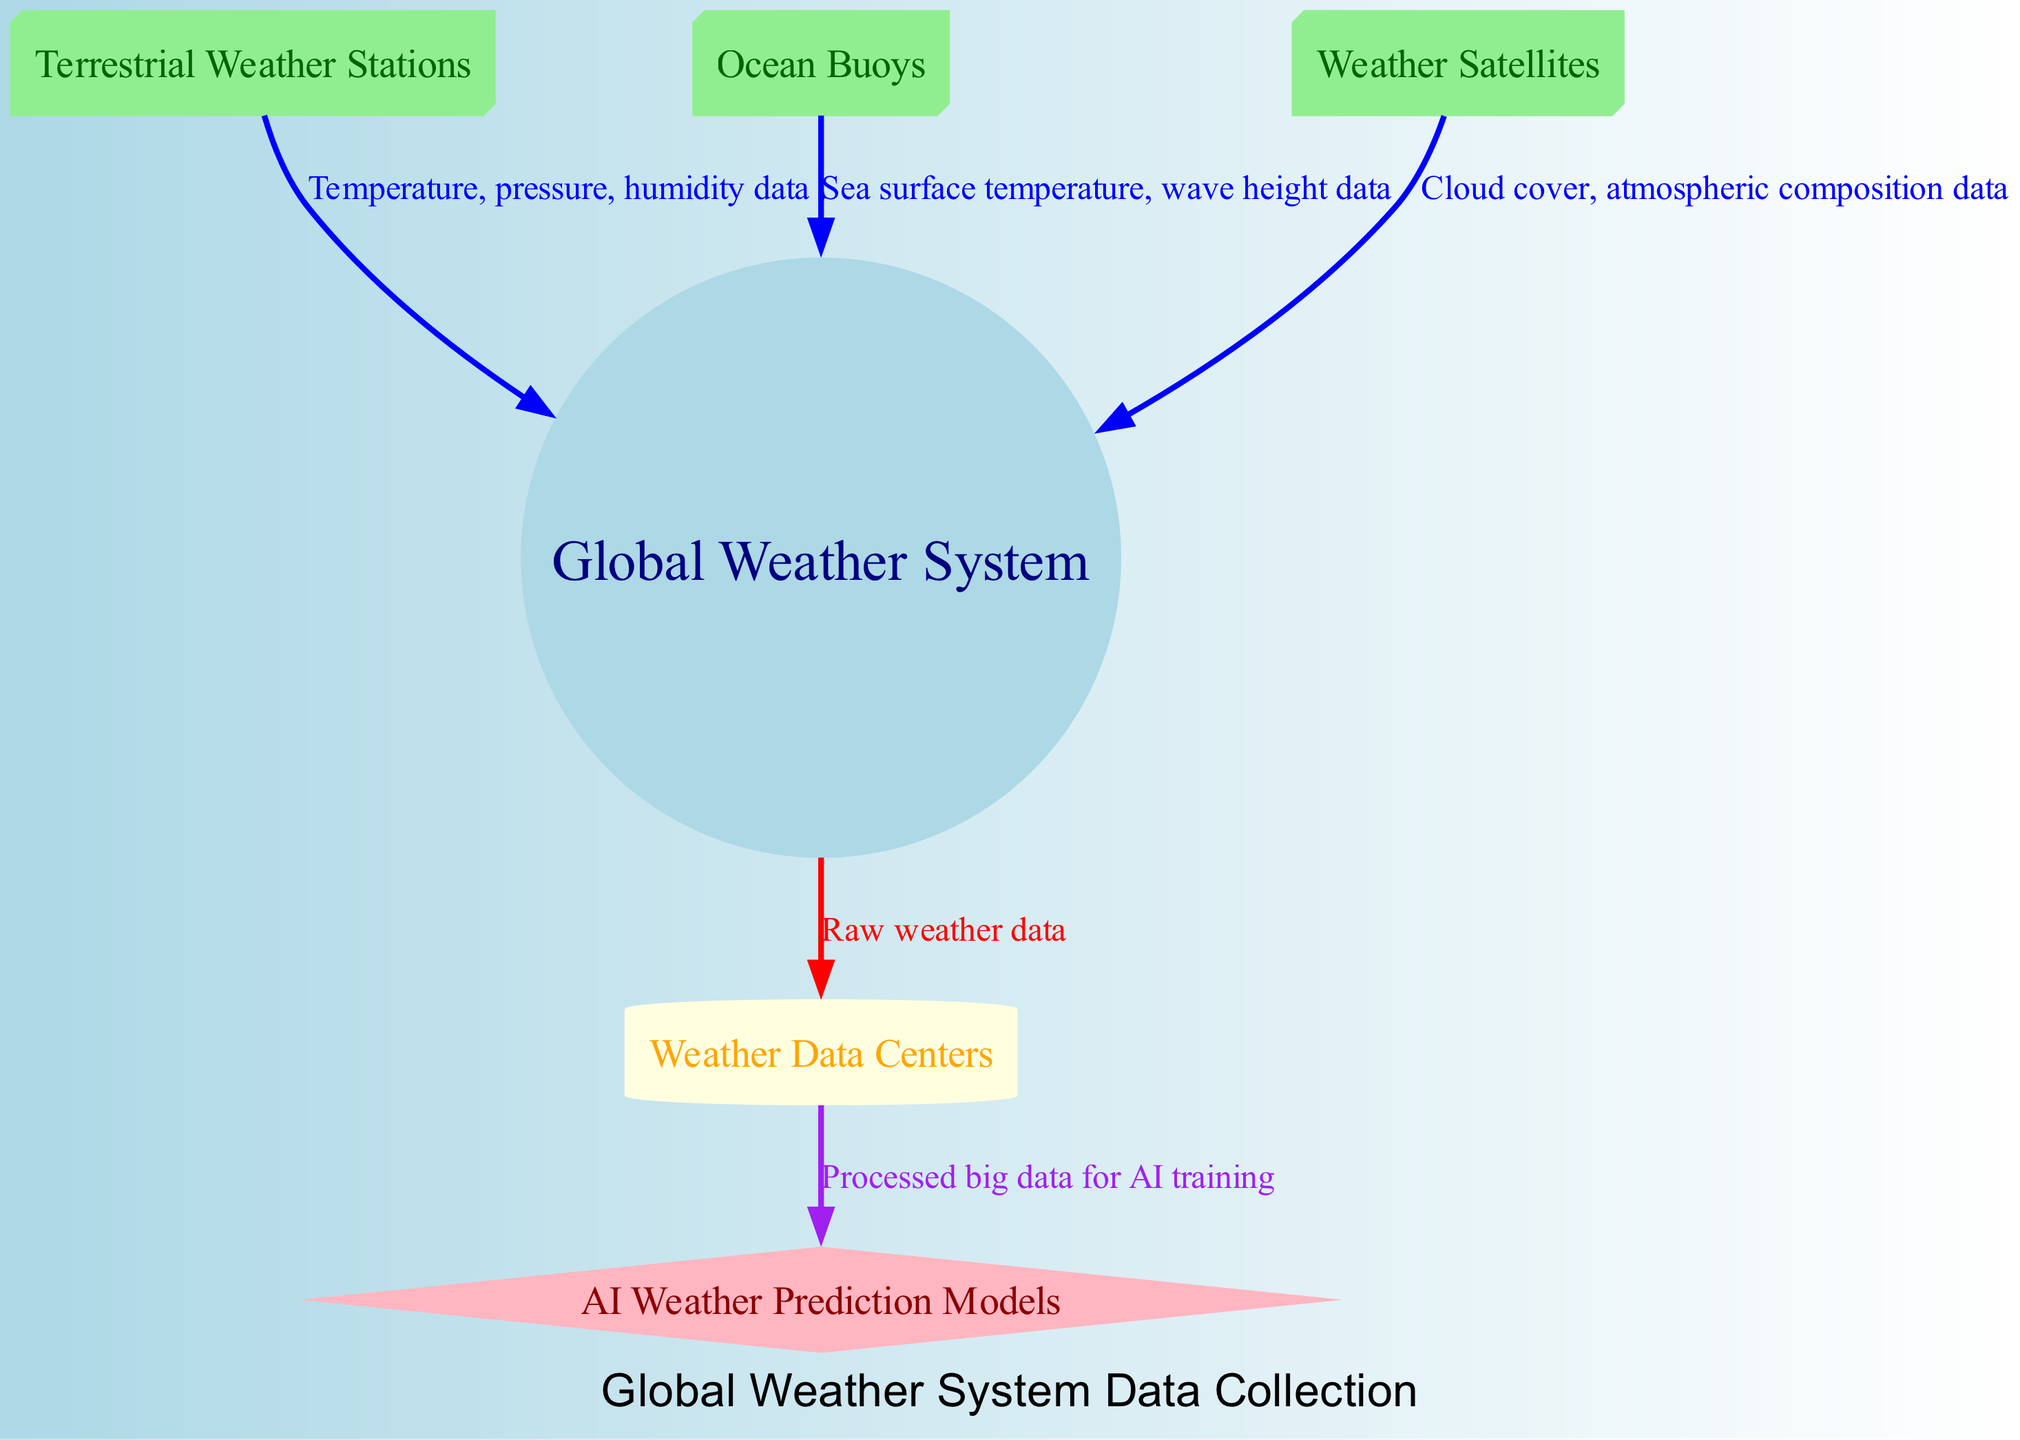What are the types of data collected from terrestrial stations? The diagram shows arrows connecting "terrestrial_stations" to "global_weather_system" labeled with "Temperature, pressure, humidity data," indicating these three types of data collected from terrestrial stations.
Answer: Temperature, pressure, humidity data Which node represents ocean data collection? The node labeled "Ocean Buoys" specifically represents ocean data collection, as shown in the diagram.
Answer: Ocean Buoys How many types of data collection sources are shown? The diagram lists three distinct data collection sources: "Terrestrial Weather Stations," "Ocean Buoys," and "Weather Satellites." Counting these gives a total of three.
Answer: 3 What data is sent from the global weather system to data centers? According to the arrow from "global_weather_system" to "data_centers," the labeled data type flowing in that direction is "Raw weather data."
Answer: Raw weather data What is the flow of processed data after data centers? The diagram indicates that processed data moves from "data_centers" to "ai_models," with the arrow labeled "Processed big data for AI training," illustrating this flow of information clearly.
Answer: Processed big data for AI training Which nodes contribute to the global weather system? The diagram illustrates that "Terrestrial Weather Stations," "Ocean Buoys," and "Weather Satellites" contribute data to the "Global Weather System," as indicated by arrows pointing to it.
Answer: Terrestrial Weather Stations, Ocean Buoys, Weather Satellites What shape represents AI weather prediction models? In the diagram, "AI Weather Prediction Models" is represented by a diamond shape, differentiating it from the other nodes.
Answer: Diamond Which data collection method involves cloud cover data? The "Weather Satellites" node is clearly connected to the global weather system and is labeled with "Cloud cover, atmospheric composition data," indicating that it is the method for cloud cover data collection.
Answer: Weather Satellites 